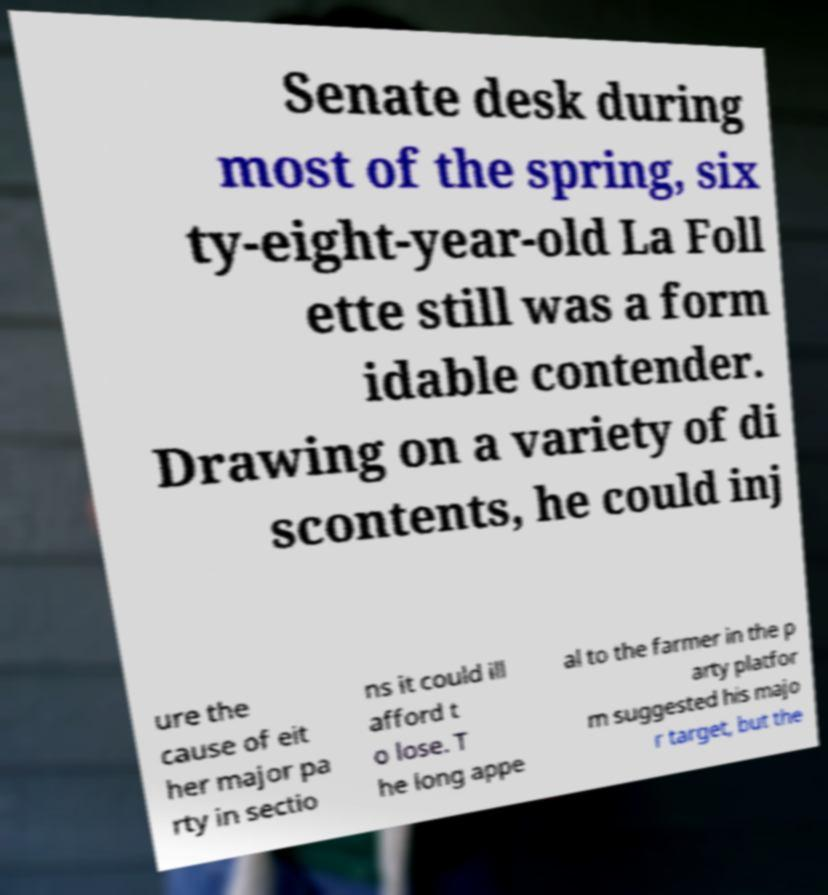For documentation purposes, I need the text within this image transcribed. Could you provide that? Senate desk during most of the spring, six ty-eight-year-old La Foll ette still was a form idable contender. Drawing on a variety of di scontents, he could inj ure the cause of eit her major pa rty in sectio ns it could ill afford t o lose. T he long appe al to the farmer in the p arty platfor m suggested his majo r target, but the 